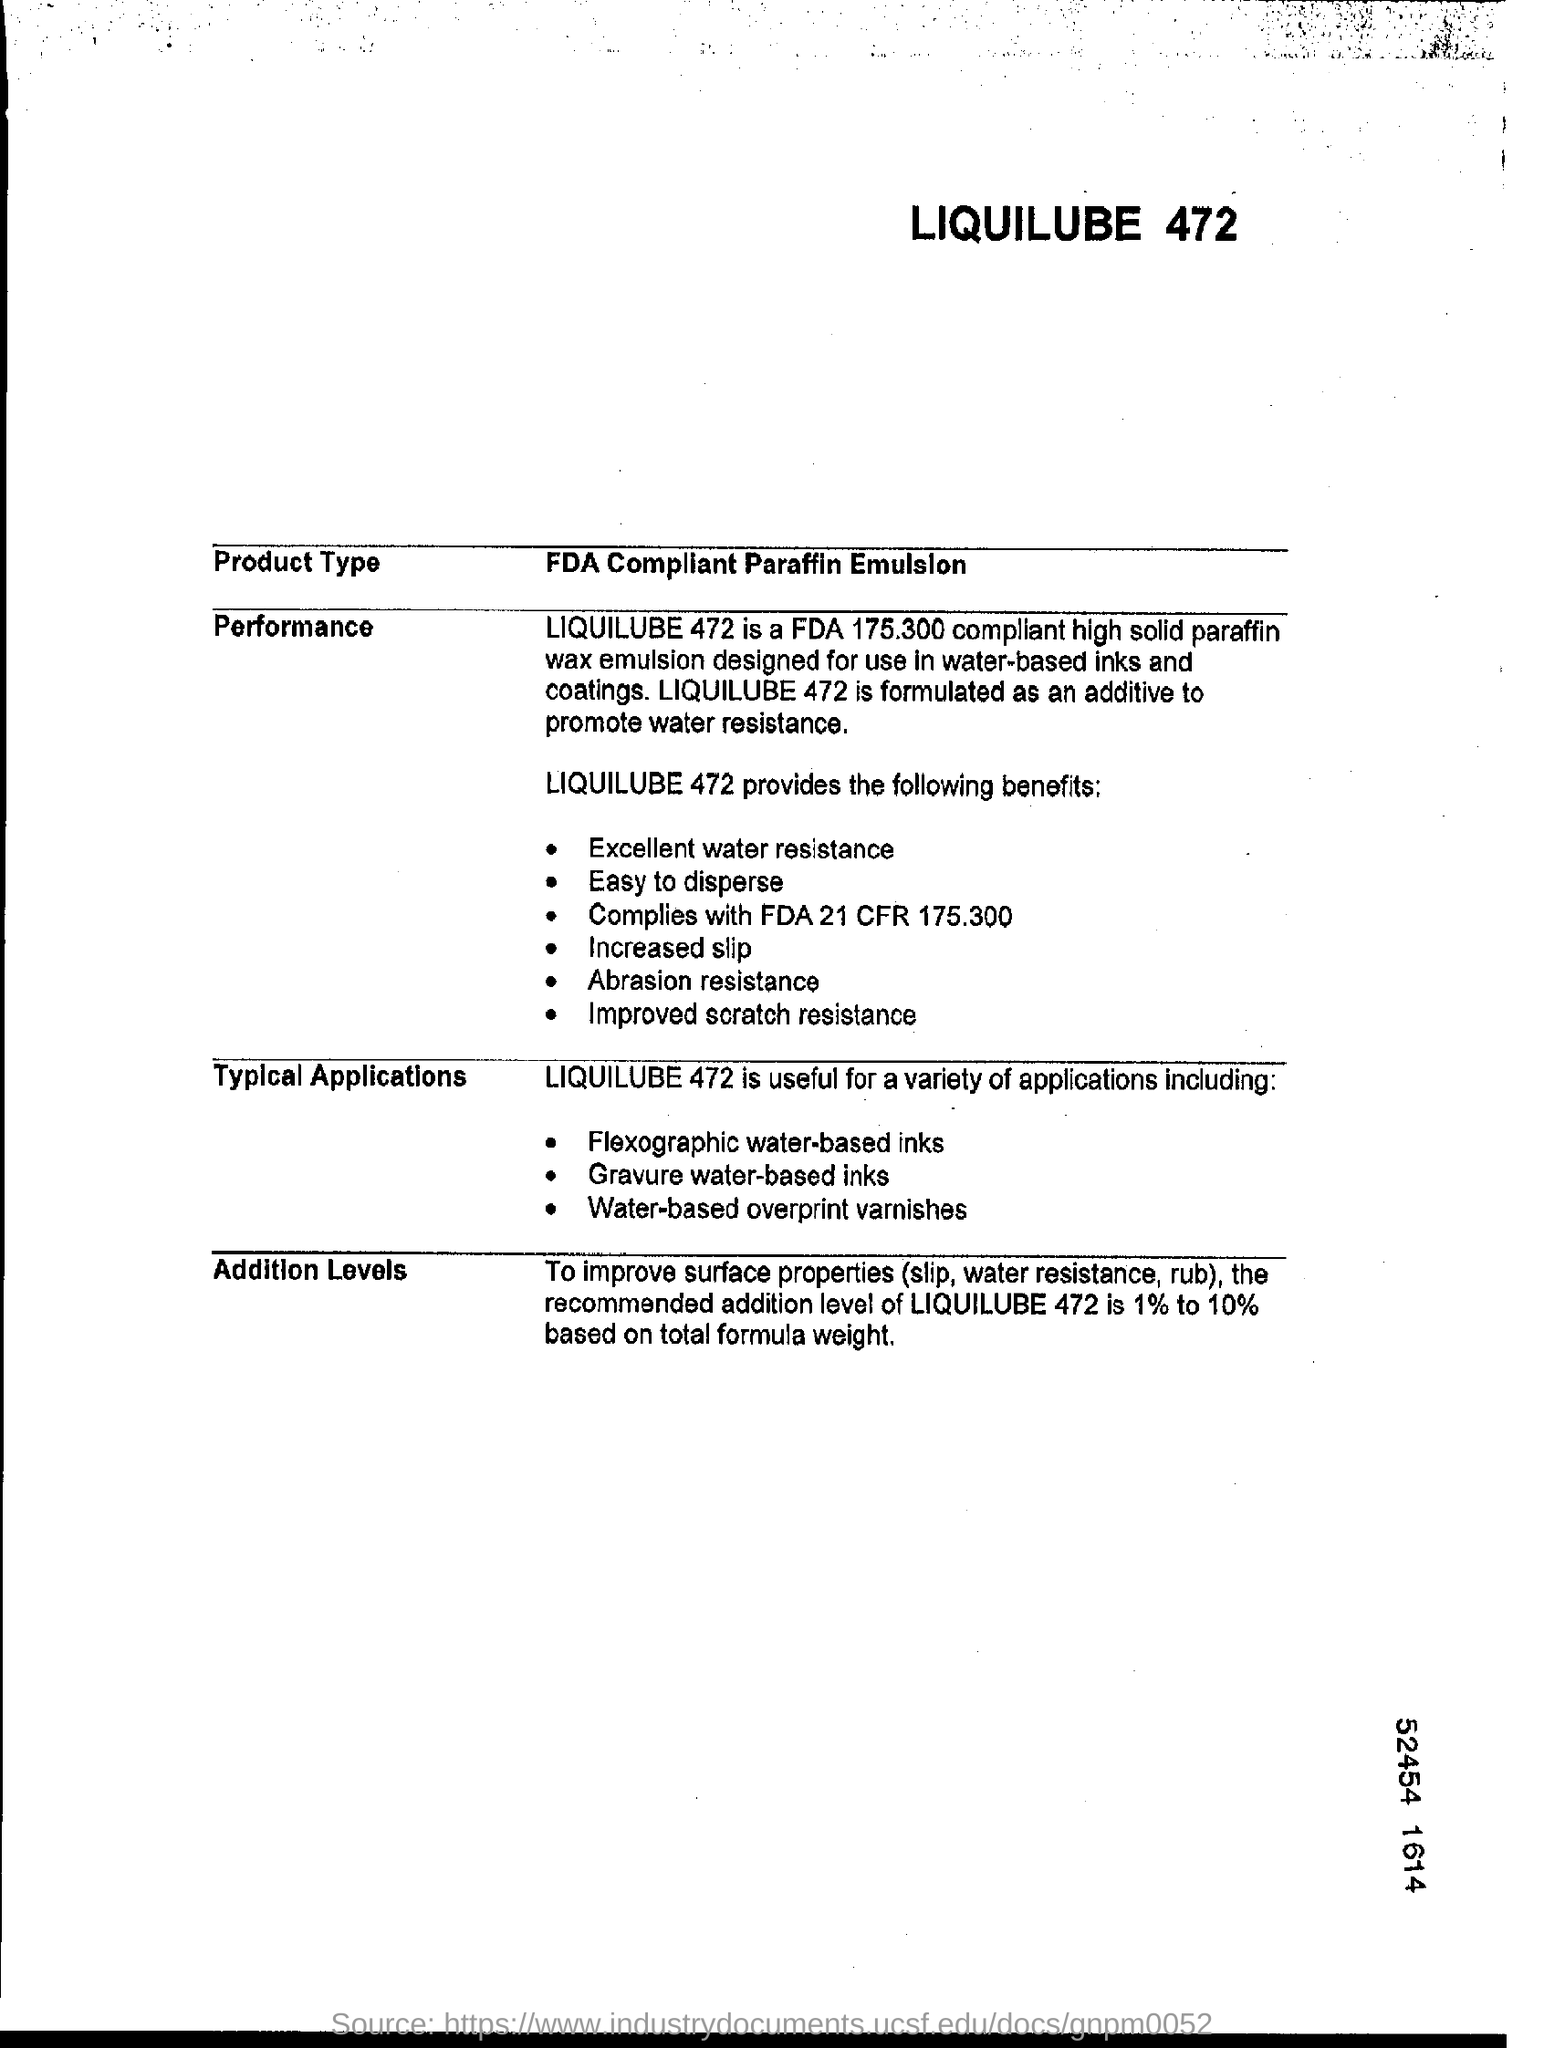What is the recommended Addition level of LIQUILUBE 472?
Offer a very short reply. 1% to 10%. 